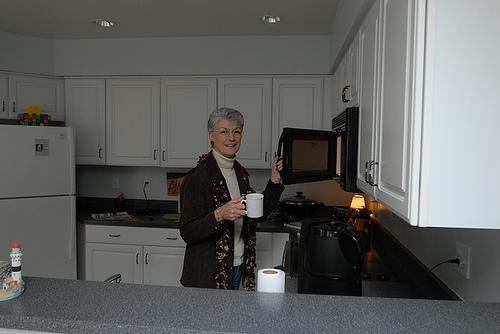Is this a big kitchen?
Be succinct. Yes. What is the woman doing?
Write a very short answer. Holding mug. How many people are in this picture?
Give a very brief answer. 1. Where would you likely see this image?
Short answer required. Kitchen. What has a door open?
Give a very brief answer. Microwave. What kind of glass is the woman holding?
Short answer required. Cup. Is there writing on the wall above the woman's head?
Quick response, please. No. What hand is she holding the mug with?
Concise answer only. Right. Is that the lady's natural hair color?
Keep it brief. Yes. Is the photo taken at ground level?
Short answer required. Yes. How many lights are visible?
Concise answer only. 3. How many colors of microwaves does the woman have?
Answer briefly. 1. How many people are above the sink?
Give a very brief answer. 1. Is the object heavy?
Concise answer only. No. What brand is the refrigerator?
Answer briefly. Whirlpool. What is the name of the gaming system on the TV stand?
Quick response, please. No gaming system. Is she in a bathroom?
Answer briefly. No. What hand is the woman holding up?
Write a very short answer. Left. Does the woman have long hair?
Be succinct. No. Is the kitchen abandoned?
Write a very short answer. No. Is there a clock on the wall?
Short answer required. No. What color are the countertops?
Short answer required. Gray. Where is the microwave?
Give a very brief answer. Above stove. What is on the girl's head?
Write a very short answer. Hair. What is she pouring?
Give a very brief answer. Coffee. Is the woman taller than the fridge?
Write a very short answer. Yes. What is the man in the lift doing?
Be succinct. Opening microwave. Is this a small kitchen?
Give a very brief answer. Yes. What is on the wall behind the girl?
Answer briefly. Cabinets. Is this room clean?
Short answer required. Yes. What is the woman holding her hand?
Answer briefly. Coffee cup. Is this a modern kitchen?
Keep it brief. Yes. Is this a man or a woman?
Keep it brief. Woman. What kind of drink is likely in the mug?
Quick response, please. Coffee. Does the fridge match the cupboards?
Short answer required. Yes. 